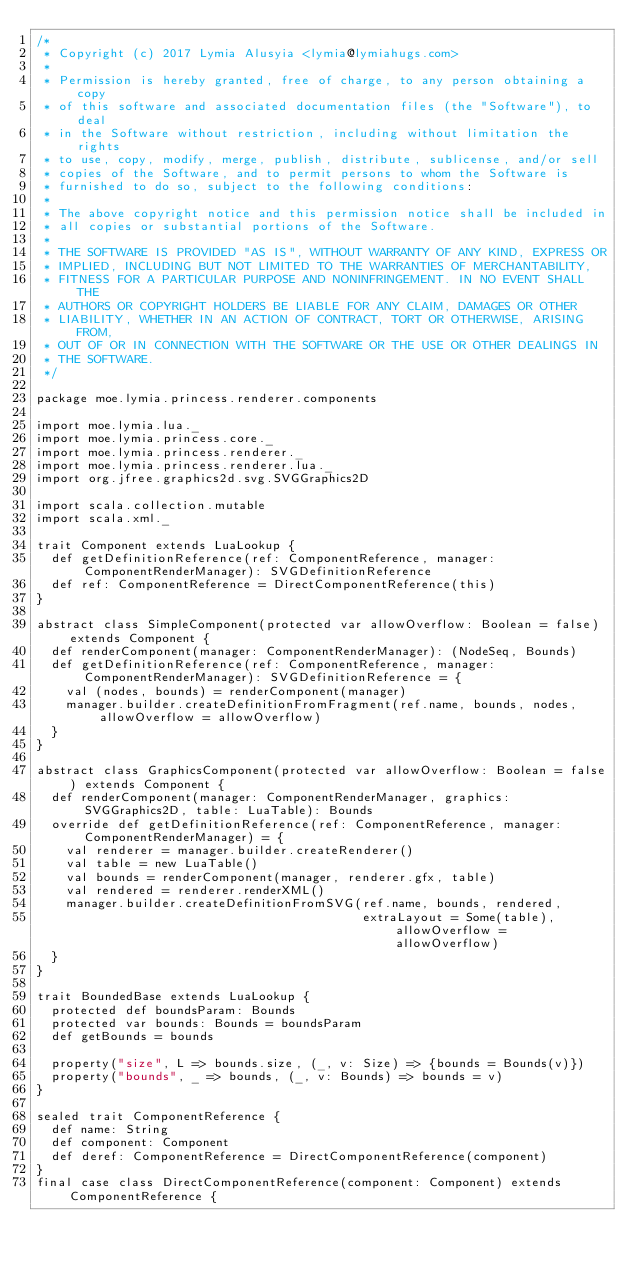Convert code to text. <code><loc_0><loc_0><loc_500><loc_500><_Scala_>/*
 * Copyright (c) 2017 Lymia Alusyia <lymia@lymiahugs.com>
 *
 * Permission is hereby granted, free of charge, to any person obtaining a copy
 * of this software and associated documentation files (the "Software"), to deal
 * in the Software without restriction, including without limitation the rights
 * to use, copy, modify, merge, publish, distribute, sublicense, and/or sell
 * copies of the Software, and to permit persons to whom the Software is
 * furnished to do so, subject to the following conditions:
 *
 * The above copyright notice and this permission notice shall be included in
 * all copies or substantial portions of the Software.
 *
 * THE SOFTWARE IS PROVIDED "AS IS", WITHOUT WARRANTY OF ANY KIND, EXPRESS OR
 * IMPLIED, INCLUDING BUT NOT LIMITED TO THE WARRANTIES OF MERCHANTABILITY,
 * FITNESS FOR A PARTICULAR PURPOSE AND NONINFRINGEMENT. IN NO EVENT SHALL THE
 * AUTHORS OR COPYRIGHT HOLDERS BE LIABLE FOR ANY CLAIM, DAMAGES OR OTHER
 * LIABILITY, WHETHER IN AN ACTION OF CONTRACT, TORT OR OTHERWISE, ARISING FROM,
 * OUT OF OR IN CONNECTION WITH THE SOFTWARE OR THE USE OR OTHER DEALINGS IN
 * THE SOFTWARE.
 */

package moe.lymia.princess.renderer.components

import moe.lymia.lua._
import moe.lymia.princess.core._
import moe.lymia.princess.renderer._
import moe.lymia.princess.renderer.lua._
import org.jfree.graphics2d.svg.SVGGraphics2D

import scala.collection.mutable
import scala.xml._

trait Component extends LuaLookup {
  def getDefinitionReference(ref: ComponentReference, manager: ComponentRenderManager): SVGDefinitionReference
  def ref: ComponentReference = DirectComponentReference(this)
}

abstract class SimpleComponent(protected var allowOverflow: Boolean = false) extends Component {
  def renderComponent(manager: ComponentRenderManager): (NodeSeq, Bounds)
  def getDefinitionReference(ref: ComponentReference, manager: ComponentRenderManager): SVGDefinitionReference = {
    val (nodes, bounds) = renderComponent(manager)
    manager.builder.createDefinitionFromFragment(ref.name, bounds, nodes, allowOverflow = allowOverflow)
  }
}

abstract class GraphicsComponent(protected var allowOverflow: Boolean = false) extends Component {
  def renderComponent(manager: ComponentRenderManager, graphics: SVGGraphics2D, table: LuaTable): Bounds
  override def getDefinitionReference(ref: ComponentReference, manager: ComponentRenderManager) = {
    val renderer = manager.builder.createRenderer()
    val table = new LuaTable()
    val bounds = renderComponent(manager, renderer.gfx, table)
    val rendered = renderer.renderXML()
    manager.builder.createDefinitionFromSVG(ref.name, bounds, rendered,
                                            extraLayout = Some(table), allowOverflow = allowOverflow)
  }
}

trait BoundedBase extends LuaLookup {
  protected def boundsParam: Bounds
  protected var bounds: Bounds = boundsParam
  def getBounds = bounds

  property("size", L => bounds.size, (_, v: Size) => {bounds = Bounds(v)})
  property("bounds", _ => bounds, (_, v: Bounds) => bounds = v)
}

sealed trait ComponentReference {
  def name: String
  def component: Component
  def deref: ComponentReference = DirectComponentReference(component)
}
final case class DirectComponentReference(component: Component) extends ComponentReference {</code> 